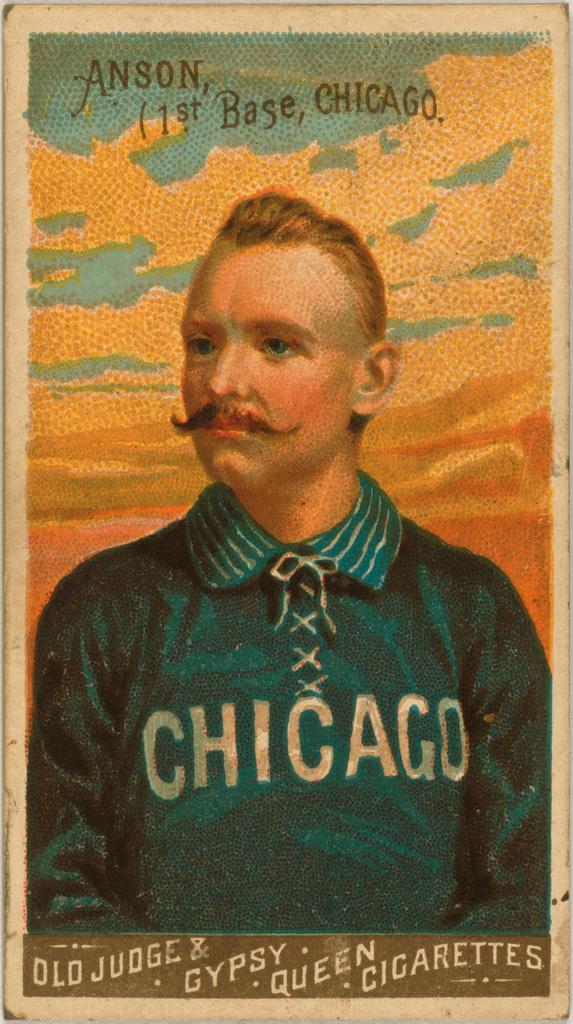What city is the person from?
Your response must be concise. Chicago. What do the words at the bottom say?
Offer a terse response. Old judge & gypsy queen cigarettes. 